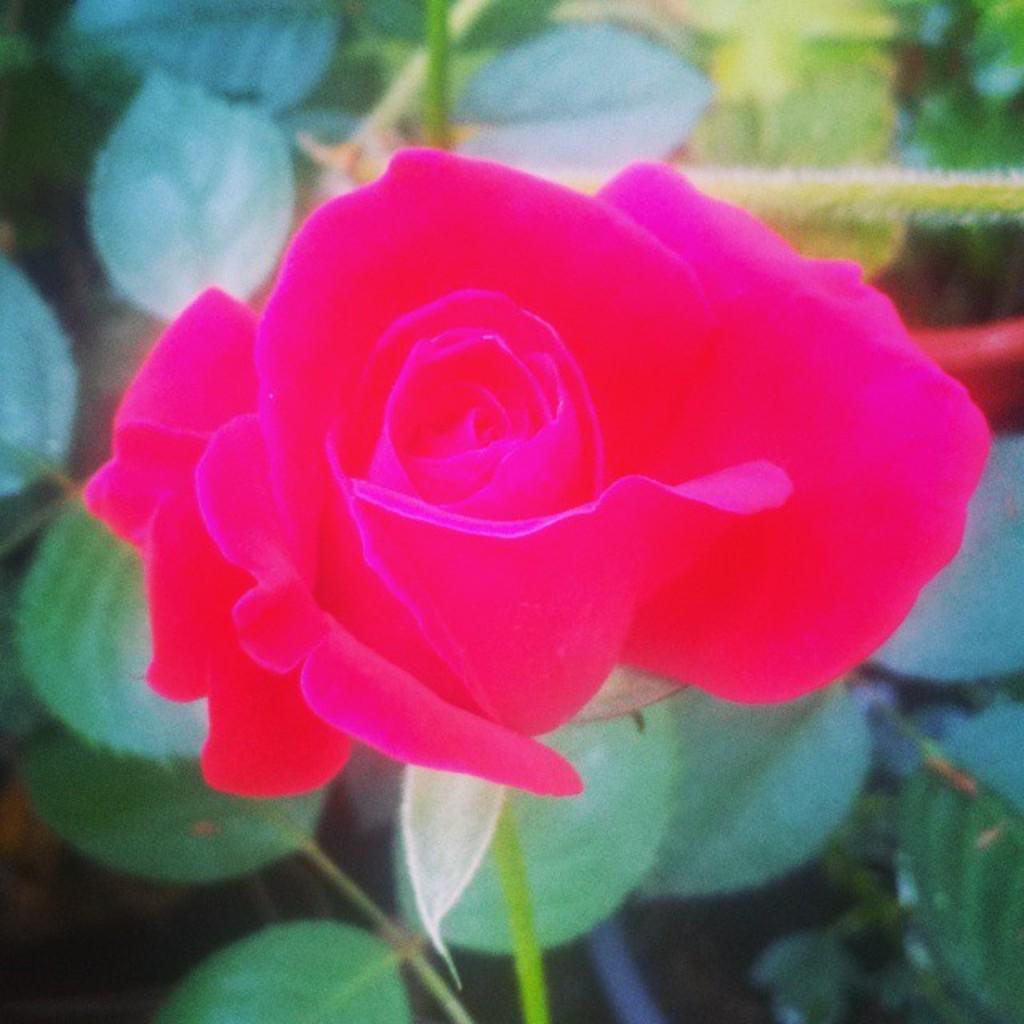Describe this image in one or two sentences. This image consists of a rose flower along with leaves. The flowers is in pink color. 